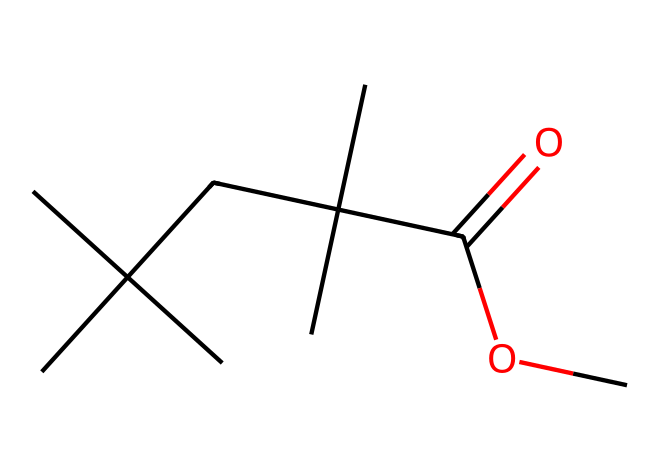What is the functional group present in this compound? The compound contains a carbonyl (C=O) and an ester (C(=O)OC), which are characteristic of functional groups. The ester functional group is derived from the reaction of an alcohol and a carboxylic acid.
Answer: ester How many carbon atoms are in the molecular structure? The chemical structure shows a total of 10 carbon atoms, counted from the main backbone and the branching groups in the SMILES representation.
Answer: 10 What type of aliphatic compound is represented in this SMILES? The SMILES notation indicates that this compound has single bonds and a carbonyl group, making it an aliphatic ester, specifically from the saturation of carbon chains.
Answer: ester What is the relationship between the carbon chains and the carbonyl group? The carbonyl group is connected to an alkyl chain with multiple branches. The structure indicates that the carbonyl is part of an ester, which links directly to a large branched carbon chain.
Answer: branch and carbonyl How many hydrogen atoms are likely bonded to the carbon skeleton in this compound? The compound's hydrogen count is derived from the formula Hn where 'n' is calculated based on the tetravalence rule. The specific count leads to 20 hydrogen atoms attached to the 10 carbon skeleton, maintaining saturation.
Answer: 20 